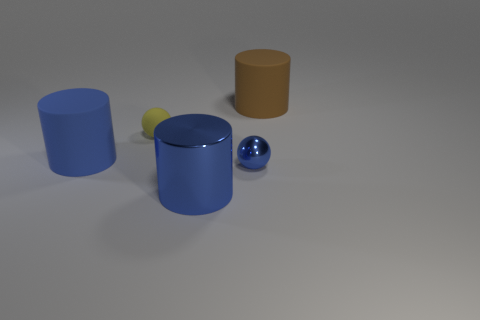Add 2 tiny yellow things. How many objects exist? 7 Subtract all cylinders. How many objects are left? 2 Add 1 yellow shiny spheres. How many yellow shiny spheres exist? 1 Subtract 1 yellow spheres. How many objects are left? 4 Subtract all big cylinders. Subtract all small metal things. How many objects are left? 1 Add 3 large brown rubber cylinders. How many large brown rubber cylinders are left? 4 